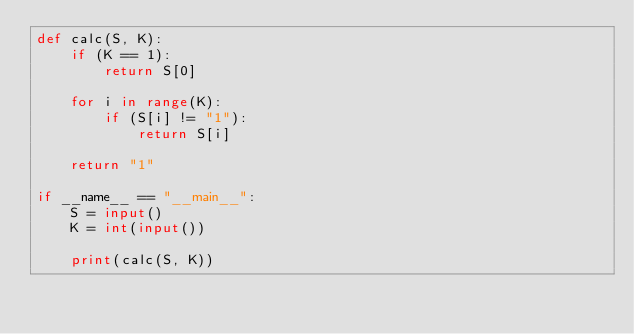Convert code to text. <code><loc_0><loc_0><loc_500><loc_500><_Python_>def calc(S, K):
    if (K == 1):
        return S[0]

    for i in range(K):
        if (S[i] != "1"):
            return S[i]
    
    return "1"

if __name__ == "__main__":
    S = input()
    K = int(input())

    print(calc(S, K))
</code> 